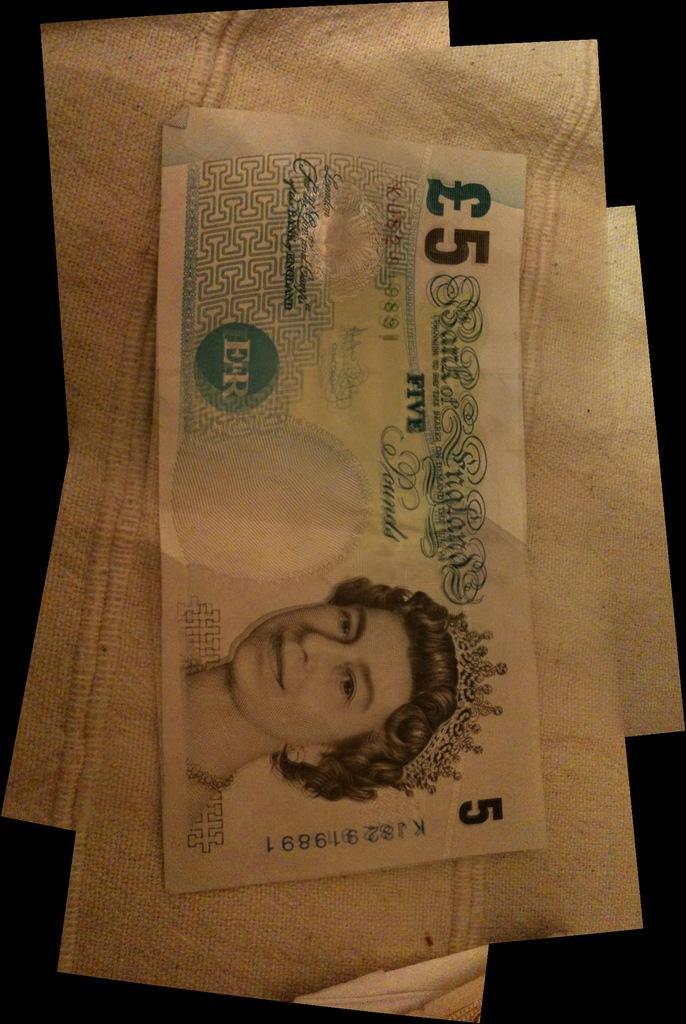How would you summarize this image in a sentence or two? In this image, we can see some posters and a currency. 